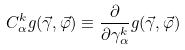<formula> <loc_0><loc_0><loc_500><loc_500>C _ { \alpha } ^ { k } g ( \vec { \gamma } , \vec { \varphi } ) \equiv \frac { \partial } { \partial \gamma _ { \alpha } ^ { k } } g ( \vec { \gamma } , \vec { \varphi } )</formula> 